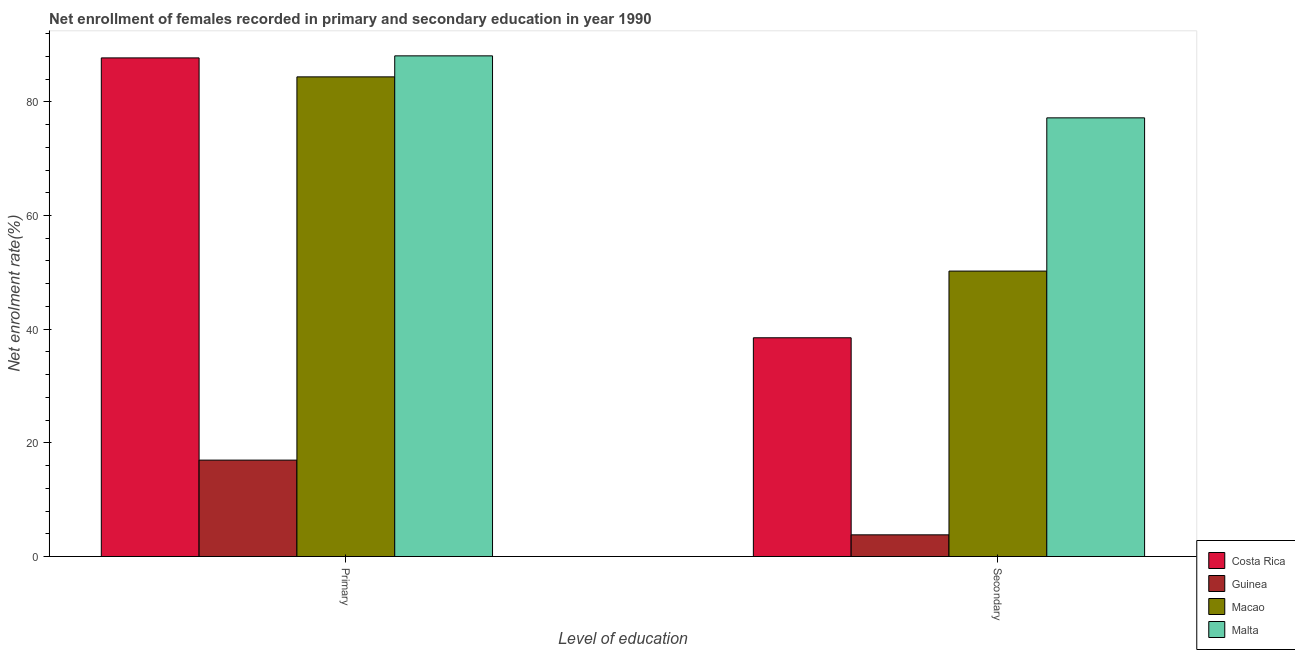How many groups of bars are there?
Give a very brief answer. 2. Are the number of bars on each tick of the X-axis equal?
Your answer should be very brief. Yes. How many bars are there on the 1st tick from the left?
Keep it short and to the point. 4. How many bars are there on the 1st tick from the right?
Keep it short and to the point. 4. What is the label of the 1st group of bars from the left?
Provide a succinct answer. Primary. What is the enrollment rate in secondary education in Macao?
Keep it short and to the point. 50.22. Across all countries, what is the maximum enrollment rate in secondary education?
Provide a succinct answer. 77.19. Across all countries, what is the minimum enrollment rate in primary education?
Make the answer very short. 16.96. In which country was the enrollment rate in secondary education maximum?
Offer a terse response. Malta. In which country was the enrollment rate in primary education minimum?
Ensure brevity in your answer.  Guinea. What is the total enrollment rate in secondary education in the graph?
Provide a succinct answer. 169.71. What is the difference between the enrollment rate in primary education in Macao and that in Costa Rica?
Give a very brief answer. -3.34. What is the difference between the enrollment rate in secondary education in Macao and the enrollment rate in primary education in Guinea?
Provide a short and direct response. 33.26. What is the average enrollment rate in primary education per country?
Your answer should be very brief. 69.3. What is the difference between the enrollment rate in primary education and enrollment rate in secondary education in Macao?
Give a very brief answer. 34.17. In how many countries, is the enrollment rate in primary education greater than 24 %?
Offer a terse response. 3. What is the ratio of the enrollment rate in primary education in Costa Rica to that in Macao?
Ensure brevity in your answer.  1.04. Is the enrollment rate in secondary education in Guinea less than that in Costa Rica?
Provide a short and direct response. Yes. In how many countries, is the enrollment rate in secondary education greater than the average enrollment rate in secondary education taken over all countries?
Your answer should be very brief. 2. What does the 4th bar from the right in Secondary represents?
Give a very brief answer. Costa Rica. How many bars are there?
Ensure brevity in your answer.  8. Are all the bars in the graph horizontal?
Provide a short and direct response. No. How many countries are there in the graph?
Provide a short and direct response. 4. What is the difference between two consecutive major ticks on the Y-axis?
Your answer should be compact. 20. Are the values on the major ticks of Y-axis written in scientific E-notation?
Give a very brief answer. No. Does the graph contain any zero values?
Offer a very short reply. No. Where does the legend appear in the graph?
Give a very brief answer. Bottom right. How are the legend labels stacked?
Ensure brevity in your answer.  Vertical. What is the title of the graph?
Provide a succinct answer. Net enrollment of females recorded in primary and secondary education in year 1990. What is the label or title of the X-axis?
Provide a succinct answer. Level of education. What is the label or title of the Y-axis?
Your answer should be compact. Net enrolment rate(%). What is the Net enrolment rate(%) in Costa Rica in Primary?
Offer a terse response. 87.73. What is the Net enrolment rate(%) in Guinea in Primary?
Ensure brevity in your answer.  16.96. What is the Net enrolment rate(%) of Macao in Primary?
Ensure brevity in your answer.  84.4. What is the Net enrolment rate(%) in Malta in Primary?
Offer a terse response. 88.09. What is the Net enrolment rate(%) of Costa Rica in Secondary?
Your answer should be compact. 38.49. What is the Net enrolment rate(%) of Guinea in Secondary?
Provide a short and direct response. 3.81. What is the Net enrolment rate(%) of Macao in Secondary?
Provide a succinct answer. 50.22. What is the Net enrolment rate(%) of Malta in Secondary?
Ensure brevity in your answer.  77.19. Across all Level of education, what is the maximum Net enrolment rate(%) of Costa Rica?
Offer a very short reply. 87.73. Across all Level of education, what is the maximum Net enrolment rate(%) in Guinea?
Offer a very short reply. 16.96. Across all Level of education, what is the maximum Net enrolment rate(%) in Macao?
Your response must be concise. 84.4. Across all Level of education, what is the maximum Net enrolment rate(%) in Malta?
Give a very brief answer. 88.09. Across all Level of education, what is the minimum Net enrolment rate(%) in Costa Rica?
Offer a very short reply. 38.49. Across all Level of education, what is the minimum Net enrolment rate(%) of Guinea?
Offer a very short reply. 3.81. Across all Level of education, what is the minimum Net enrolment rate(%) in Macao?
Provide a short and direct response. 50.22. Across all Level of education, what is the minimum Net enrolment rate(%) in Malta?
Your response must be concise. 77.19. What is the total Net enrolment rate(%) in Costa Rica in the graph?
Keep it short and to the point. 126.22. What is the total Net enrolment rate(%) of Guinea in the graph?
Your answer should be compact. 20.78. What is the total Net enrolment rate(%) in Macao in the graph?
Make the answer very short. 134.62. What is the total Net enrolment rate(%) of Malta in the graph?
Your answer should be very brief. 165.28. What is the difference between the Net enrolment rate(%) in Costa Rica in Primary and that in Secondary?
Ensure brevity in your answer.  49.25. What is the difference between the Net enrolment rate(%) in Guinea in Primary and that in Secondary?
Your answer should be compact. 13.15. What is the difference between the Net enrolment rate(%) in Macao in Primary and that in Secondary?
Give a very brief answer. 34.17. What is the difference between the Net enrolment rate(%) in Malta in Primary and that in Secondary?
Provide a succinct answer. 10.91. What is the difference between the Net enrolment rate(%) in Costa Rica in Primary and the Net enrolment rate(%) in Guinea in Secondary?
Ensure brevity in your answer.  83.92. What is the difference between the Net enrolment rate(%) of Costa Rica in Primary and the Net enrolment rate(%) of Macao in Secondary?
Your answer should be very brief. 37.51. What is the difference between the Net enrolment rate(%) in Costa Rica in Primary and the Net enrolment rate(%) in Malta in Secondary?
Ensure brevity in your answer.  10.55. What is the difference between the Net enrolment rate(%) in Guinea in Primary and the Net enrolment rate(%) in Macao in Secondary?
Offer a very short reply. -33.26. What is the difference between the Net enrolment rate(%) in Guinea in Primary and the Net enrolment rate(%) in Malta in Secondary?
Give a very brief answer. -60.22. What is the difference between the Net enrolment rate(%) in Macao in Primary and the Net enrolment rate(%) in Malta in Secondary?
Ensure brevity in your answer.  7.21. What is the average Net enrolment rate(%) of Costa Rica per Level of education?
Keep it short and to the point. 63.11. What is the average Net enrolment rate(%) in Guinea per Level of education?
Make the answer very short. 10.39. What is the average Net enrolment rate(%) in Macao per Level of education?
Make the answer very short. 67.31. What is the average Net enrolment rate(%) in Malta per Level of education?
Your answer should be compact. 82.64. What is the difference between the Net enrolment rate(%) in Costa Rica and Net enrolment rate(%) in Guinea in Primary?
Make the answer very short. 70.77. What is the difference between the Net enrolment rate(%) of Costa Rica and Net enrolment rate(%) of Macao in Primary?
Your answer should be compact. 3.34. What is the difference between the Net enrolment rate(%) of Costa Rica and Net enrolment rate(%) of Malta in Primary?
Your response must be concise. -0.36. What is the difference between the Net enrolment rate(%) of Guinea and Net enrolment rate(%) of Macao in Primary?
Keep it short and to the point. -67.44. What is the difference between the Net enrolment rate(%) of Guinea and Net enrolment rate(%) of Malta in Primary?
Your answer should be very brief. -71.13. What is the difference between the Net enrolment rate(%) of Macao and Net enrolment rate(%) of Malta in Primary?
Your answer should be very brief. -3.7. What is the difference between the Net enrolment rate(%) of Costa Rica and Net enrolment rate(%) of Guinea in Secondary?
Provide a short and direct response. 34.67. What is the difference between the Net enrolment rate(%) in Costa Rica and Net enrolment rate(%) in Macao in Secondary?
Your response must be concise. -11.74. What is the difference between the Net enrolment rate(%) of Costa Rica and Net enrolment rate(%) of Malta in Secondary?
Make the answer very short. -38.7. What is the difference between the Net enrolment rate(%) of Guinea and Net enrolment rate(%) of Macao in Secondary?
Make the answer very short. -46.41. What is the difference between the Net enrolment rate(%) in Guinea and Net enrolment rate(%) in Malta in Secondary?
Provide a succinct answer. -73.37. What is the difference between the Net enrolment rate(%) of Macao and Net enrolment rate(%) of Malta in Secondary?
Offer a very short reply. -26.96. What is the ratio of the Net enrolment rate(%) of Costa Rica in Primary to that in Secondary?
Your response must be concise. 2.28. What is the ratio of the Net enrolment rate(%) of Guinea in Primary to that in Secondary?
Your answer should be very brief. 4.45. What is the ratio of the Net enrolment rate(%) in Macao in Primary to that in Secondary?
Provide a short and direct response. 1.68. What is the ratio of the Net enrolment rate(%) of Malta in Primary to that in Secondary?
Provide a succinct answer. 1.14. What is the difference between the highest and the second highest Net enrolment rate(%) of Costa Rica?
Give a very brief answer. 49.25. What is the difference between the highest and the second highest Net enrolment rate(%) in Guinea?
Make the answer very short. 13.15. What is the difference between the highest and the second highest Net enrolment rate(%) of Macao?
Keep it short and to the point. 34.17. What is the difference between the highest and the second highest Net enrolment rate(%) of Malta?
Ensure brevity in your answer.  10.91. What is the difference between the highest and the lowest Net enrolment rate(%) in Costa Rica?
Your answer should be very brief. 49.25. What is the difference between the highest and the lowest Net enrolment rate(%) of Guinea?
Your answer should be compact. 13.15. What is the difference between the highest and the lowest Net enrolment rate(%) in Macao?
Ensure brevity in your answer.  34.17. What is the difference between the highest and the lowest Net enrolment rate(%) of Malta?
Provide a succinct answer. 10.91. 